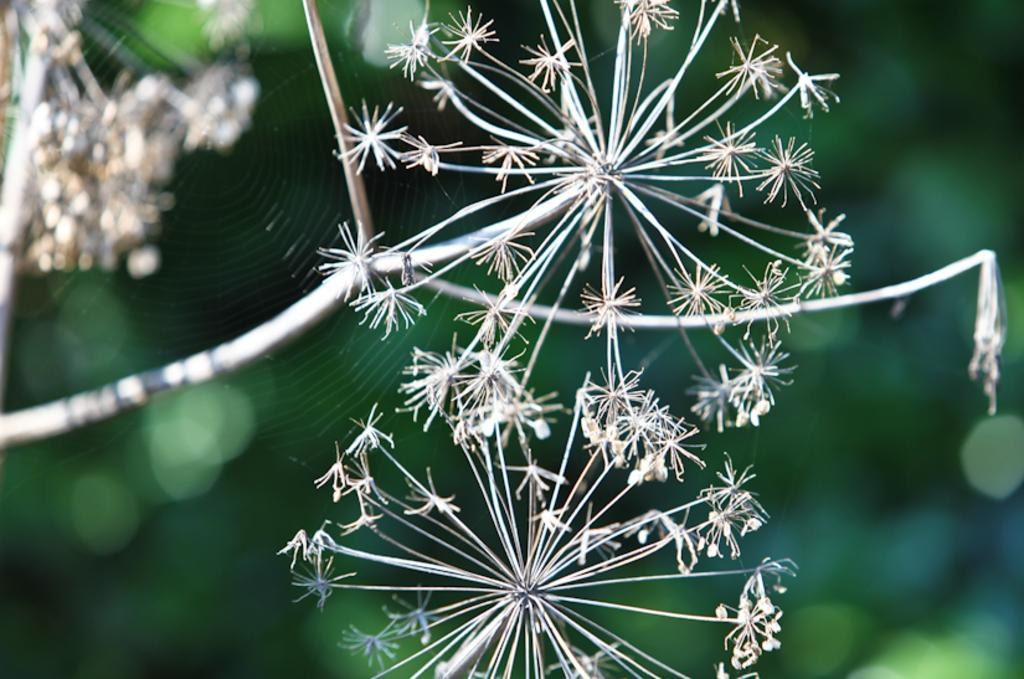What type of plants can be seen in the image? There are flowers in the image. What is the structure made by the spider in the image? A spider's net is visible in the image. What color is the curtain behind the man in the image? There is no man or curtain present in the image. How does the spider fold its net in the image? Spiders do not fold their nets; they create them by spinning silk. 